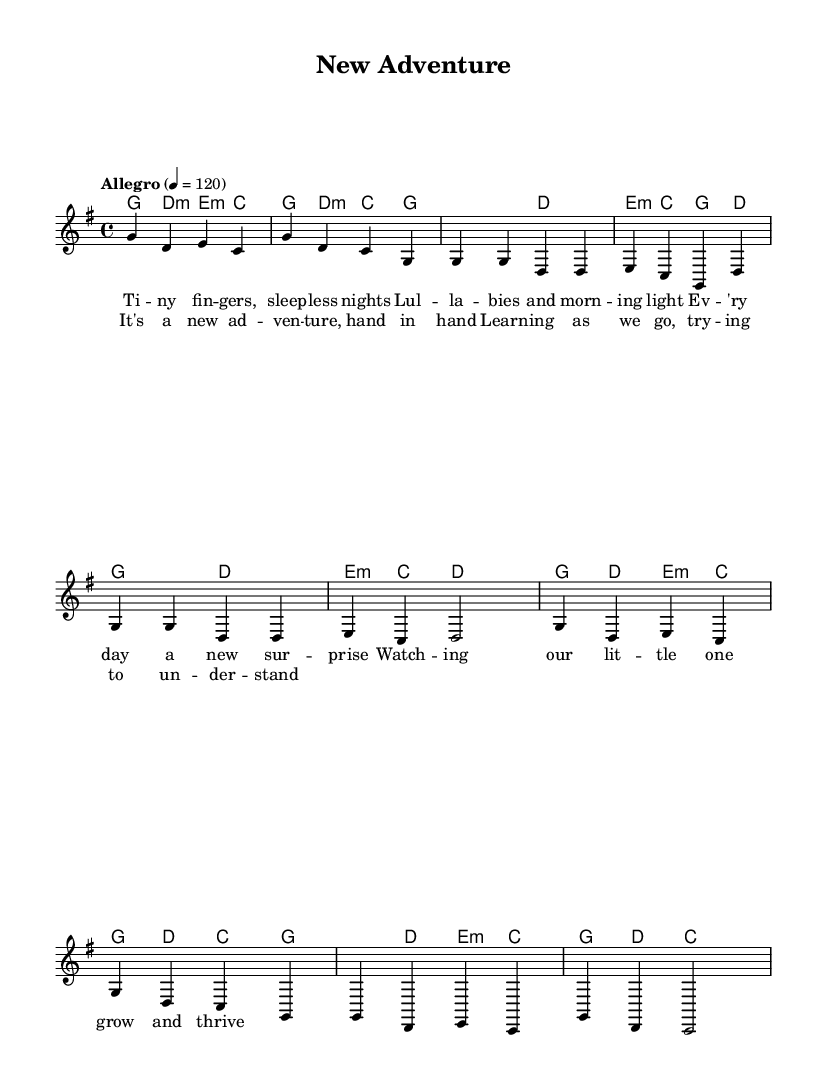What is the key signature of this music? The key signature is G major, as indicated by the presence of one sharp (F#) in the key signature section of the sheet music.
Answer: G major What is the time signature of this piece? The time signature shown in the sheet music is 4/4, which means there are four beats in each measure and the quarter note gets one beat.
Answer: 4/4 What is the tempo marking for this music? The tempo marking indicates "Allegro" with a metronome setting of 120 beats per minute, meaning that the piece should be played fast and lively.
Answer: Allegro, 120 How many measures are in the chorus? The chorus has a total of four measures, as shown by counting the groups of notes within the chorus section of the sheet music.
Answer: Four measures How many times is the word "new" mentioned in the lyrics? The word "new" appears three times in the lyrics, which can be counted from the provided lyric sections of the score.
Answer: Three times What type of harmony is used in this folk tune? The harmony is primarily built using major and minor chords, which are typical in folk music to create a simple and accessible sound.
Answer: Major and minor chords What is the overall theme of the lyrics? The theme revolves around the joys and challenges of new parenthood, focusing on love, surprises, and growth within the family context.
Answer: New parenthood 